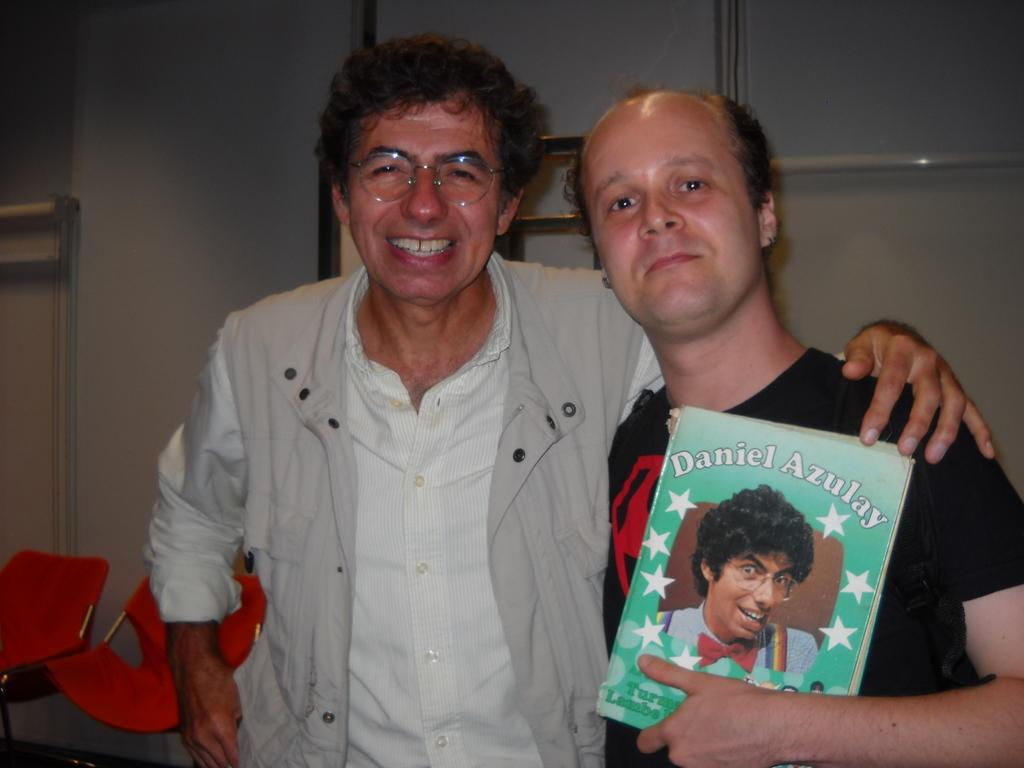How many people are in the image? There are two men in the image. What are the men doing in the image? The men are seeing and smiling. Who is holding a book in the image? There is a person holding a book in the image. What can be seen in the background of the image? There is a wall and chairs in the background of the image. What type of grape is being used as a paperweight on the book in the image? There is no grape present in the image, let alone being used as a paperweight on the book. 